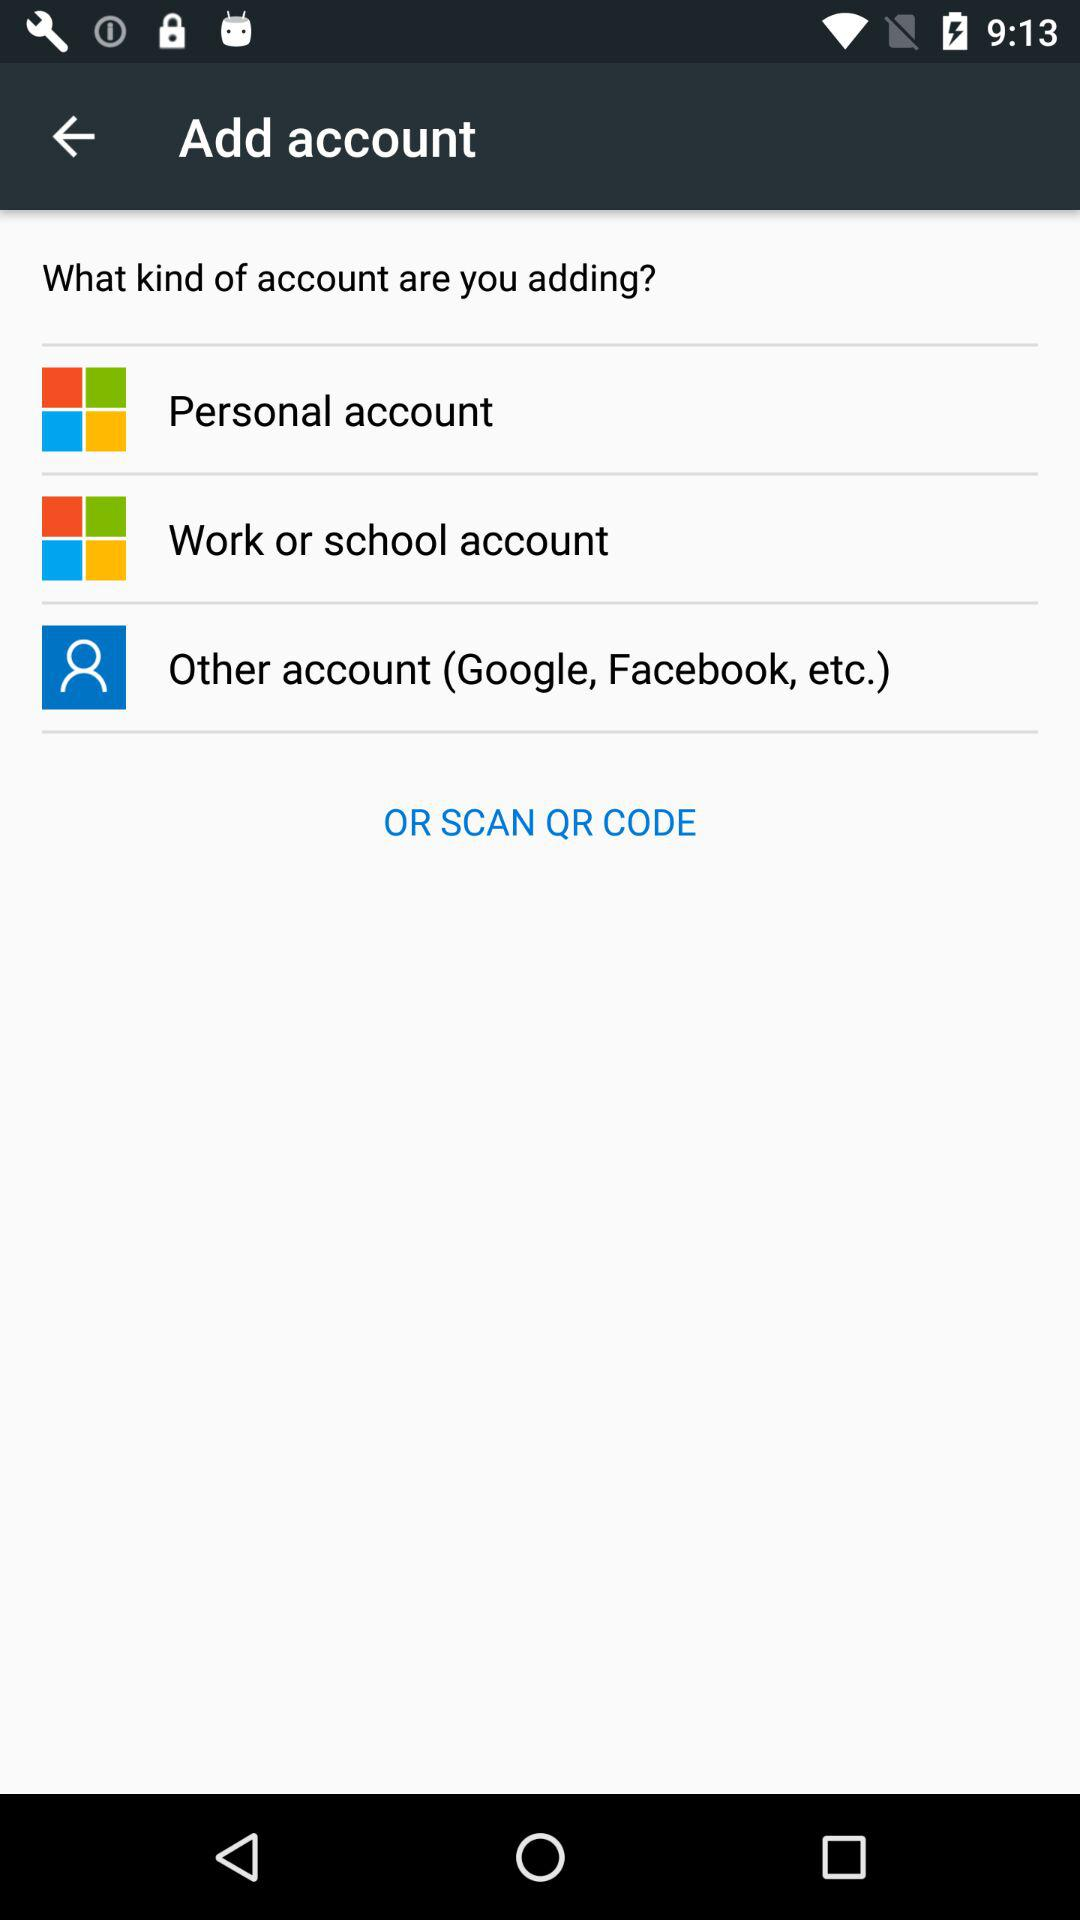How many types of accounts can I add?
Answer the question using a single word or phrase. 3 